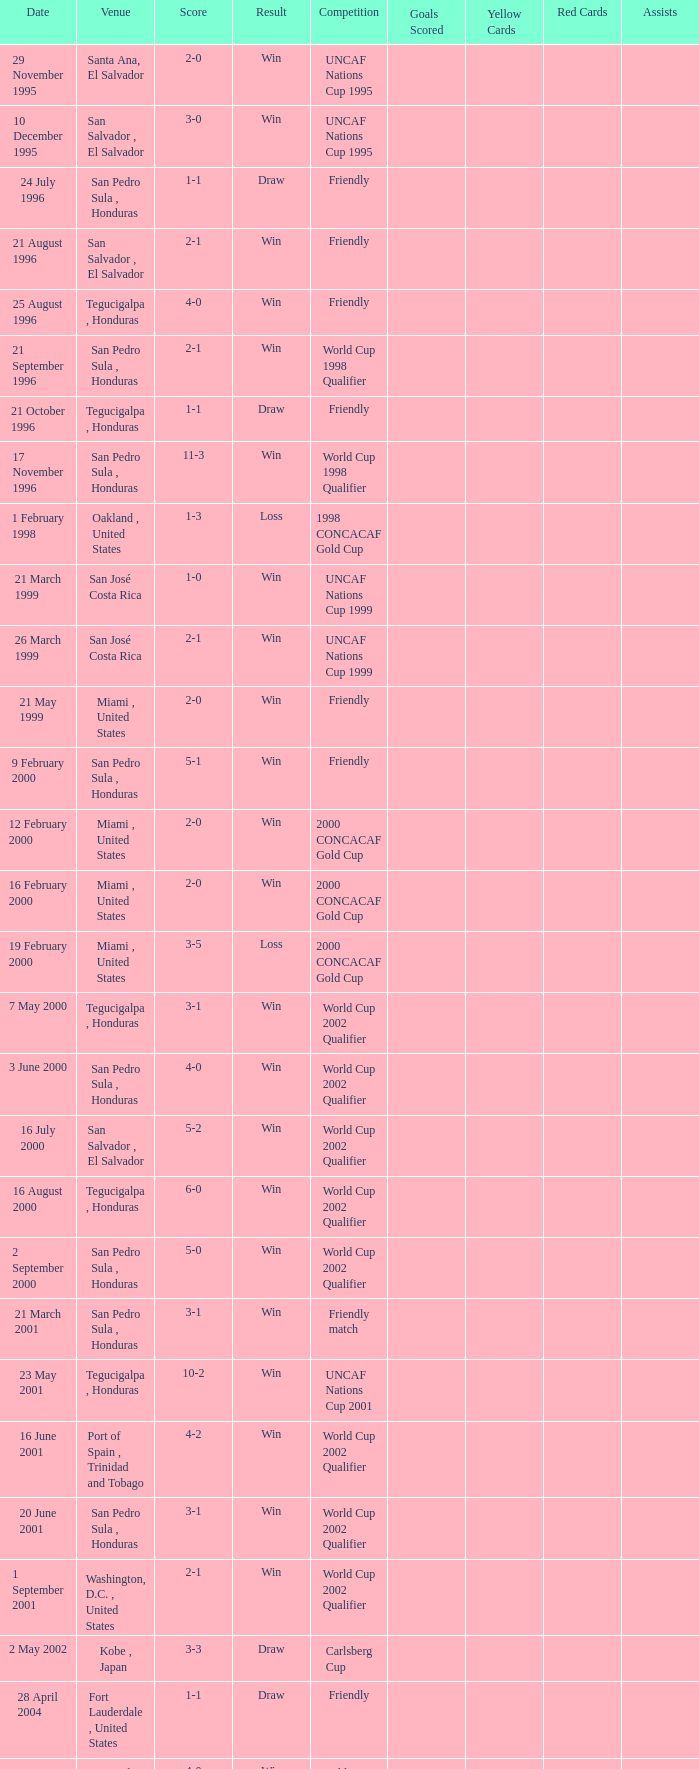What is the score for the date may 7, 2000? 3-1. 